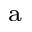<formula> <loc_0><loc_0><loc_500><loc_500>^ { a }</formula> 